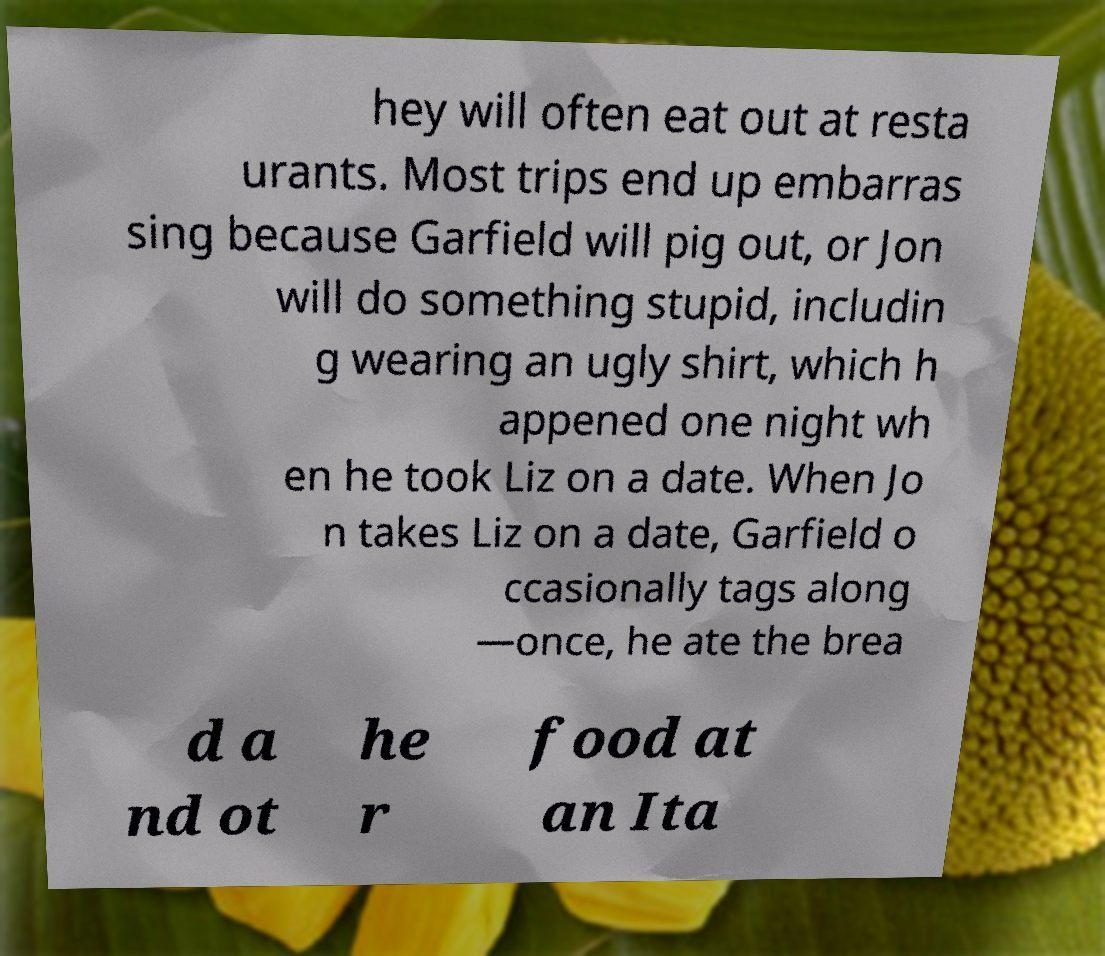I need the written content from this picture converted into text. Can you do that? hey will often eat out at resta urants. Most trips end up embarras sing because Garfield will pig out, or Jon will do something stupid, includin g wearing an ugly shirt, which h appened one night wh en he took Liz on a date. When Jo n takes Liz on a date, Garfield o ccasionally tags along —once, he ate the brea d a nd ot he r food at an Ita 